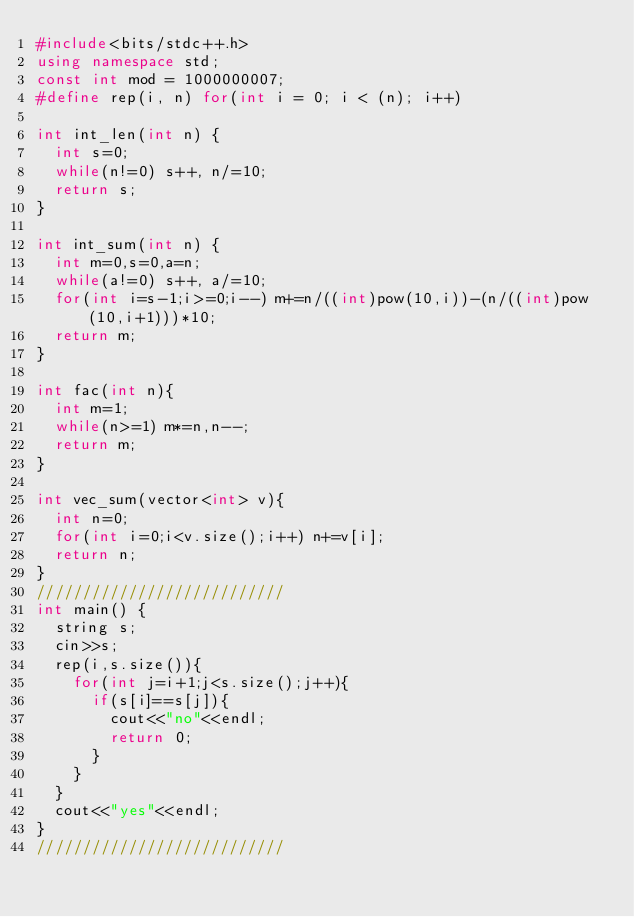Convert code to text. <code><loc_0><loc_0><loc_500><loc_500><_C++_>#include<bits/stdc++.h>
using namespace std;
const int mod = 1000000007;
#define rep(i, n) for(int i = 0; i < (n); i++)

int int_len(int n) {
  int s=0;
  while(n!=0) s++, n/=10;
  return s;
}

int int_sum(int n) {
  int m=0,s=0,a=n;
  while(a!=0) s++, a/=10;
  for(int i=s-1;i>=0;i--) m+=n/((int)pow(10,i))-(n/((int)pow(10,i+1)))*10;
  return m;
}

int fac(int n){
  int m=1;
  while(n>=1) m*=n,n--;
  return m;
}

int vec_sum(vector<int> v){
  int n=0;
  for(int i=0;i<v.size();i++) n+=v[i];
  return n;
}
///////////////////////////
int main() {
  string s;
  cin>>s;
  rep(i,s.size()){
    for(int j=i+1;j<s.size();j++){
      if(s[i]==s[j]){
        cout<<"no"<<endl;
        return 0;
      }
    }
  }
  cout<<"yes"<<endl;
}
///////////////////////////</code> 